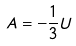Convert formula to latex. <formula><loc_0><loc_0><loc_500><loc_500>A = - \frac { 1 } { 3 } U</formula> 